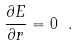Convert formula to latex. <formula><loc_0><loc_0><loc_500><loc_500>\frac { \partial E } { \partial r } = 0 \ .</formula> 